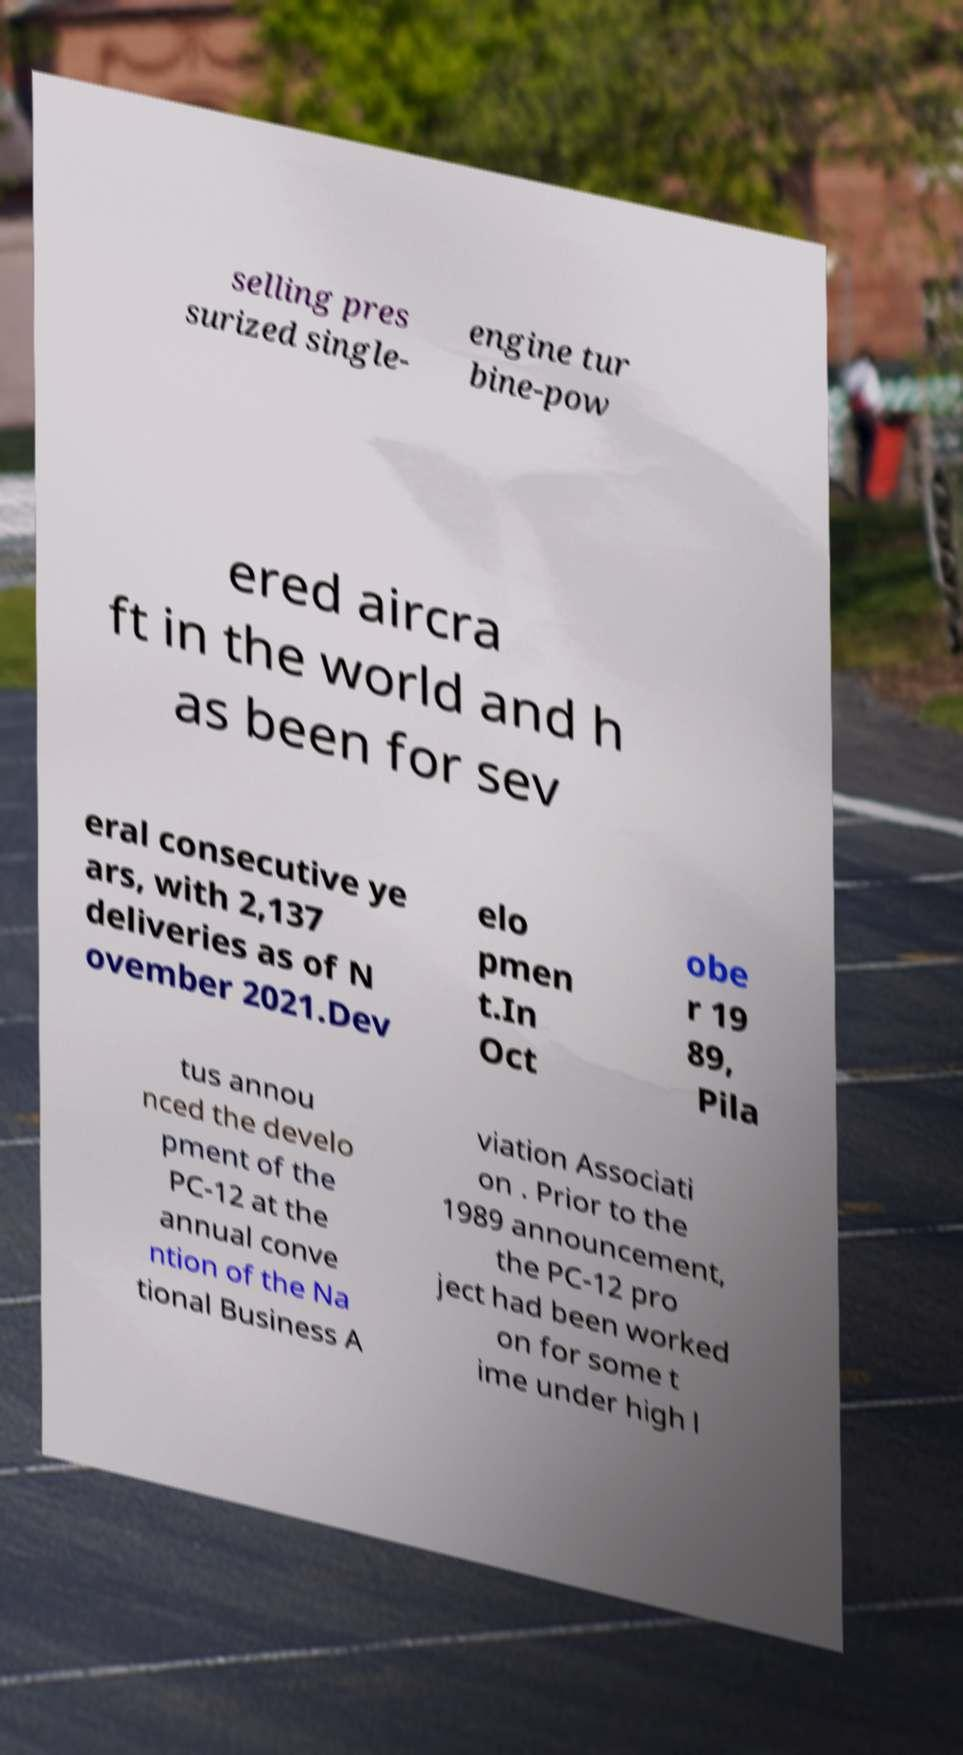I need the written content from this picture converted into text. Can you do that? selling pres surized single- engine tur bine-pow ered aircra ft in the world and h as been for sev eral consecutive ye ars, with 2,137 deliveries as of N ovember 2021.Dev elo pmen t.In Oct obe r 19 89, Pila tus annou nced the develo pment of the PC-12 at the annual conve ntion of the Na tional Business A viation Associati on . Prior to the 1989 announcement, the PC-12 pro ject had been worked on for some t ime under high l 